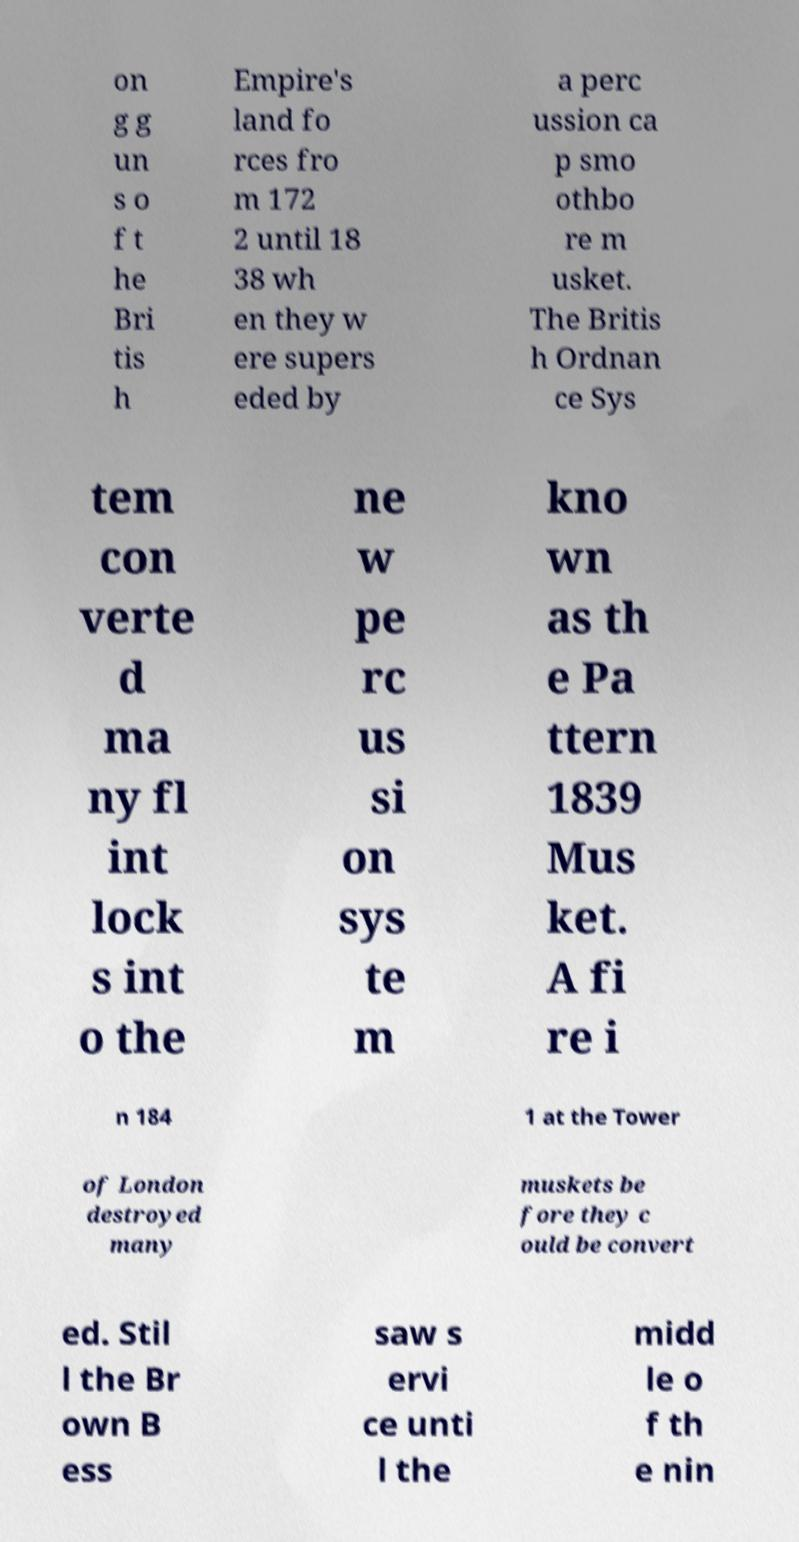What messages or text are displayed in this image? I need them in a readable, typed format. on g g un s o f t he Bri tis h Empire's land fo rces fro m 172 2 until 18 38 wh en they w ere supers eded by a perc ussion ca p smo othbo re m usket. The Britis h Ordnan ce Sys tem con verte d ma ny fl int lock s int o the ne w pe rc us si on sys te m kno wn as th e Pa ttern 1839 Mus ket. A fi re i n 184 1 at the Tower of London destroyed many muskets be fore they c ould be convert ed. Stil l the Br own B ess saw s ervi ce unti l the midd le o f th e nin 